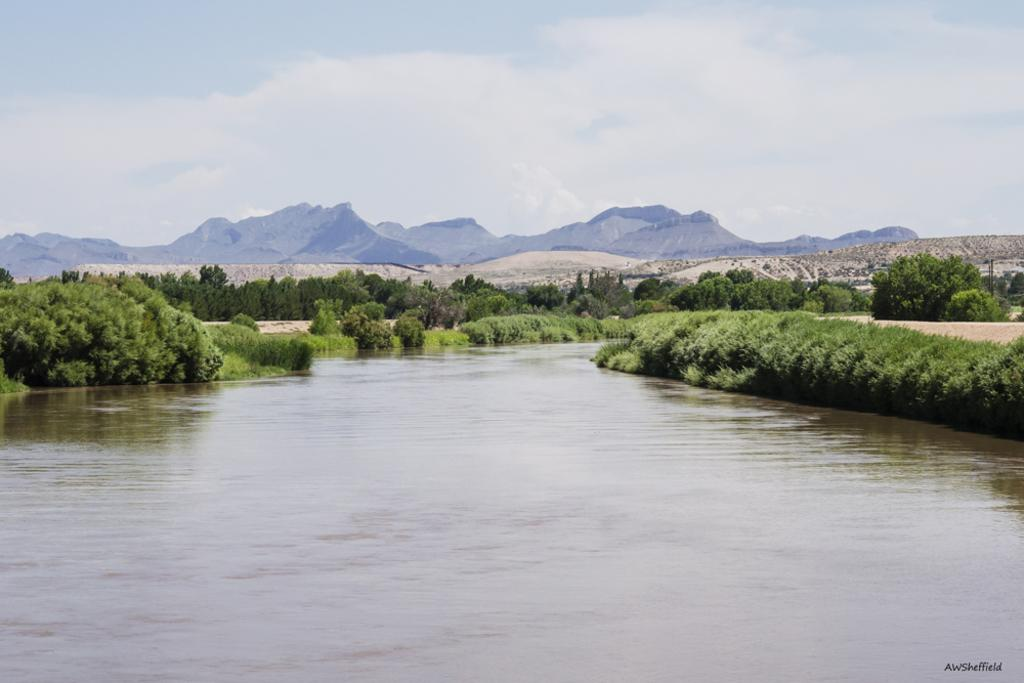What is located at the bottom of the image? There is a lake at the bottom of the image. What can be seen in the background of the image? There are trees and hills in the background of the image. What is visible in the sky in the image? The sky is visible in the background of the image. What invention is being demonstrated in the image? There is no invention being demonstrated in the image; it features a lake, trees, hills, and the sky. Can you tell me who was born in the image? There is no birth depicted in the image; it is a landscape scene. 